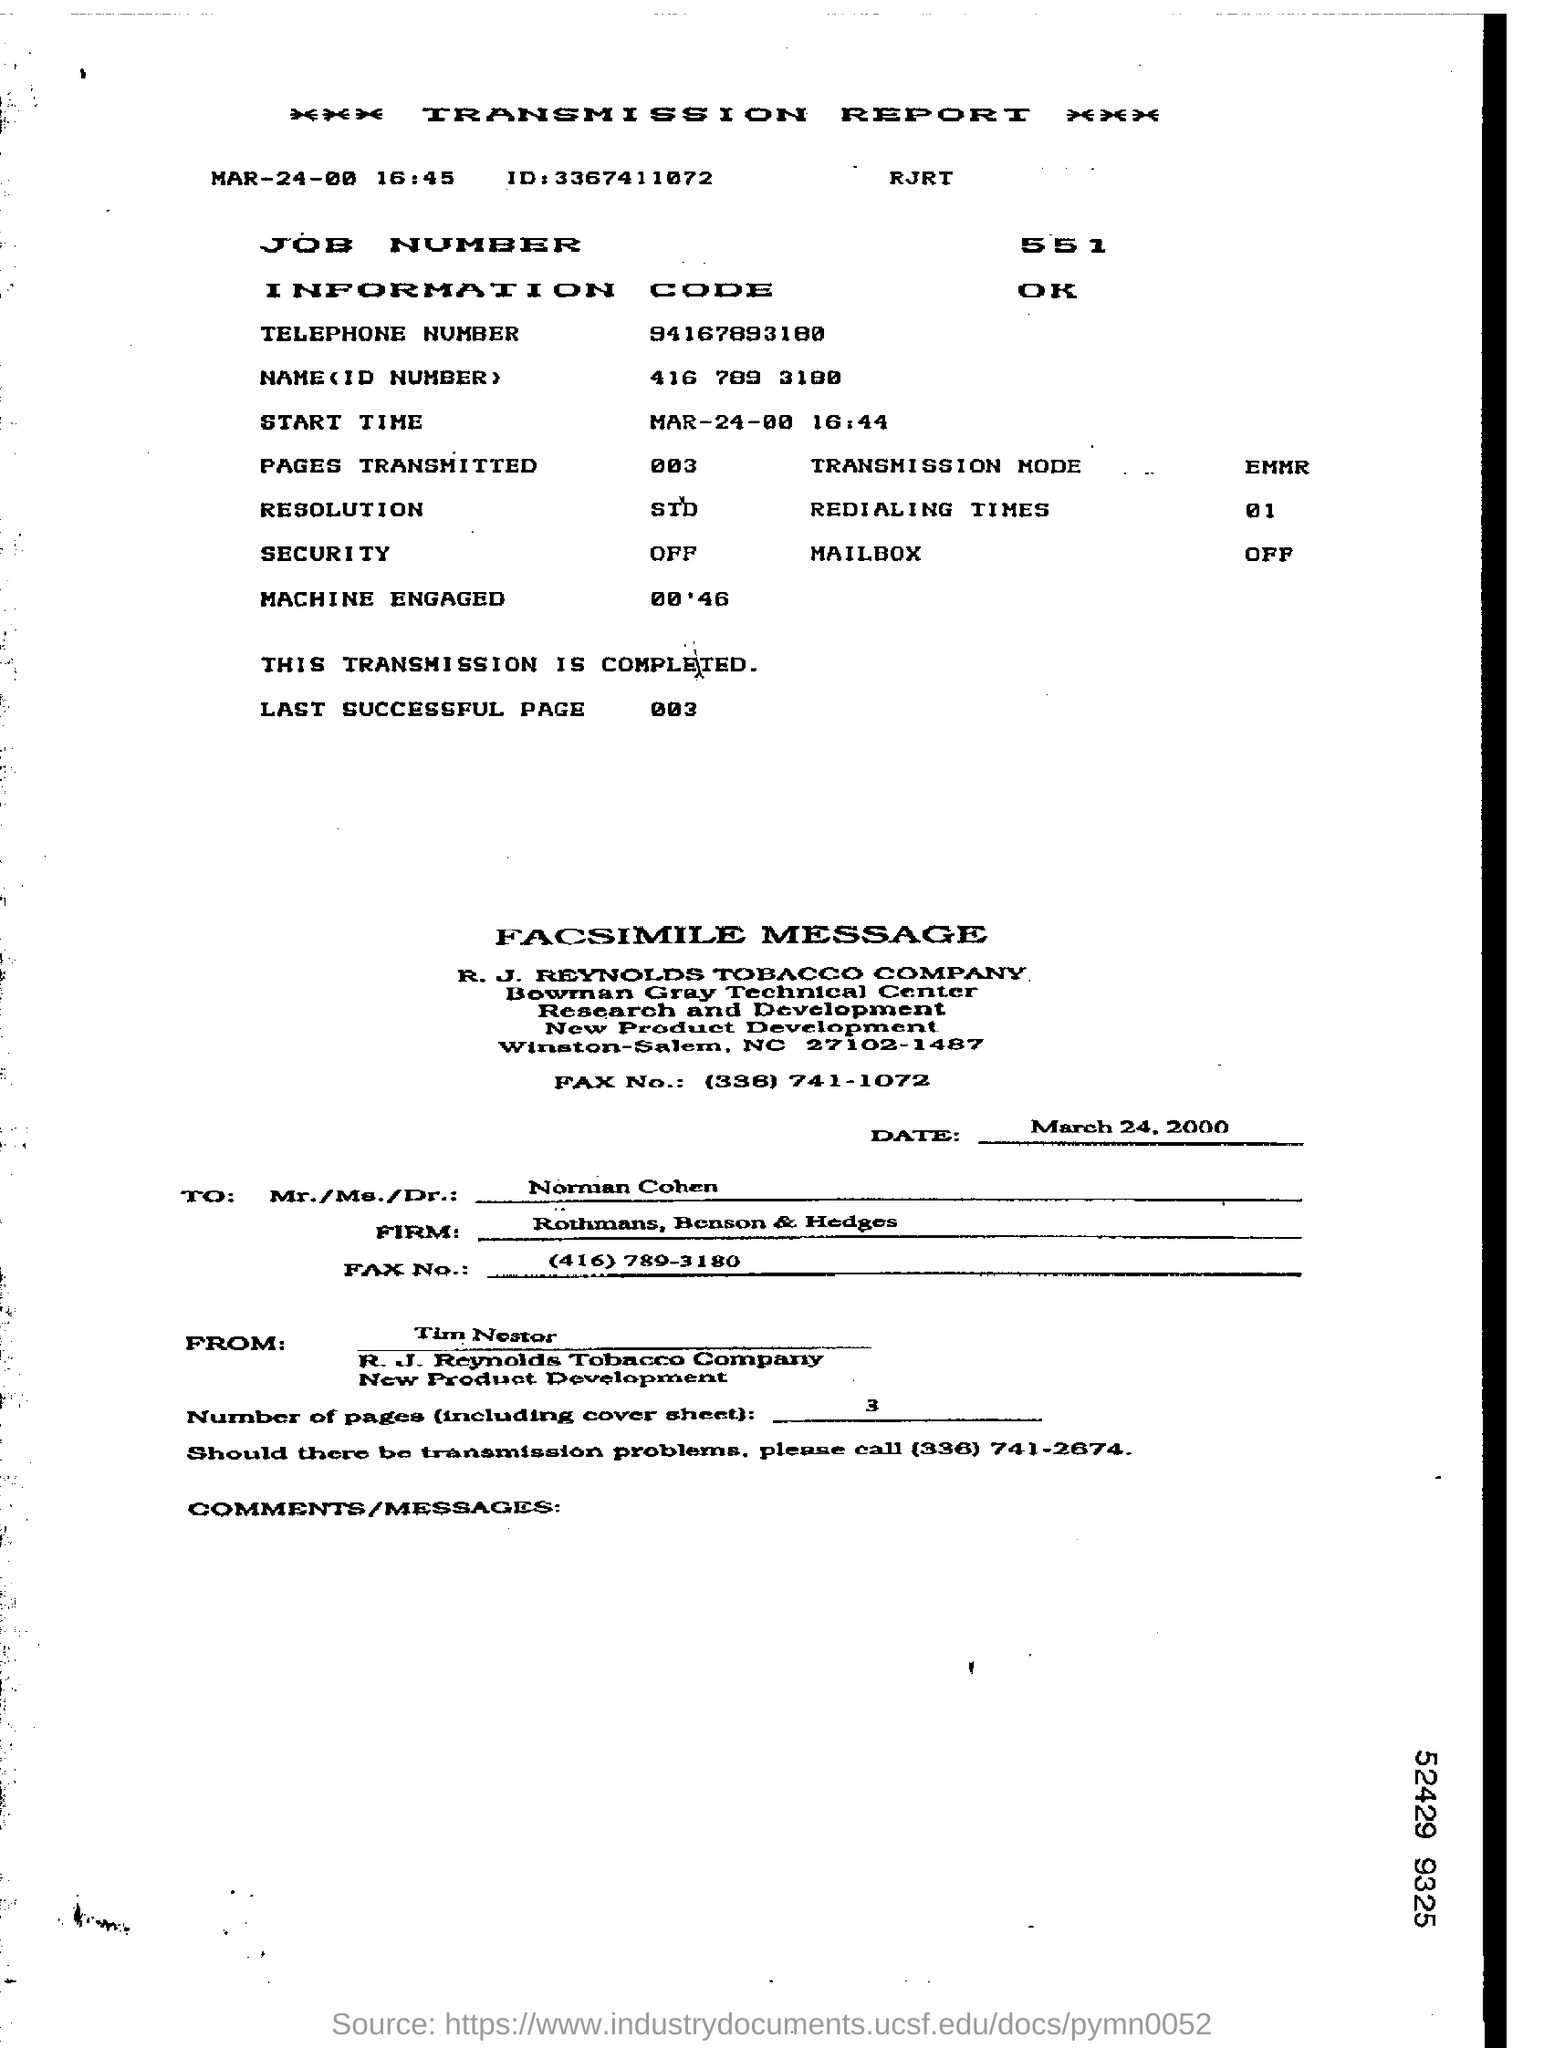To whom, the Fax is being sent?
Offer a terse response. Norman Cohen. Who is the sender of the FAX?
Ensure brevity in your answer.  Tim Nestor. How many pages are there in the fax including cover sheet?
Your response must be concise. 3. What is the ID mentioned in the transmission report?
Give a very brief answer. 3367411072. What is the transmission mode mentioned in the report?
Ensure brevity in your answer.  EMMR. What is the Job Number mentioned in the transmission report?
Your answer should be compact. 551. What is the redialing times mentioned in the report?
Offer a terse response. 01. 